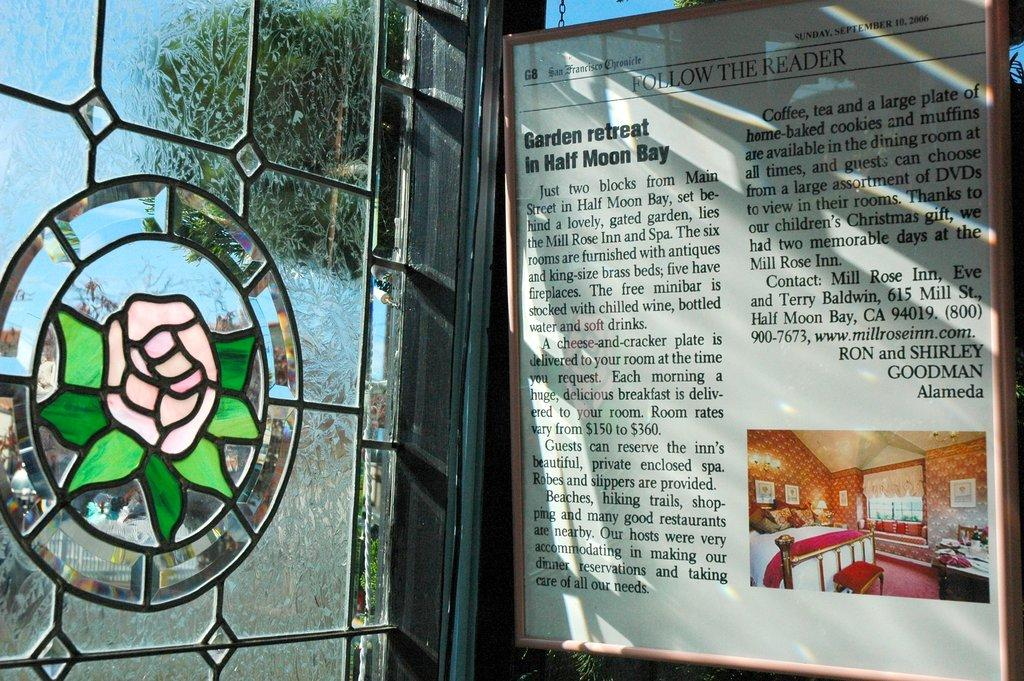What is on the board that is visible in the image? There is a board with text in the image, and there is also a picture on the board. What can be seen in the window in the image? There is a window with a flower design in the image. What part of the natural environment is visible in the image? Some part of the sky is visible in the image. Is there an argument happening between the money and the room in the image? There is no money or room present in the image, and therefore no such argument can be observed. 